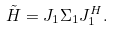Convert formula to latex. <formula><loc_0><loc_0><loc_500><loc_500>\tilde { H } = J _ { 1 } \Sigma _ { 1 } J _ { 1 } ^ { H } .</formula> 